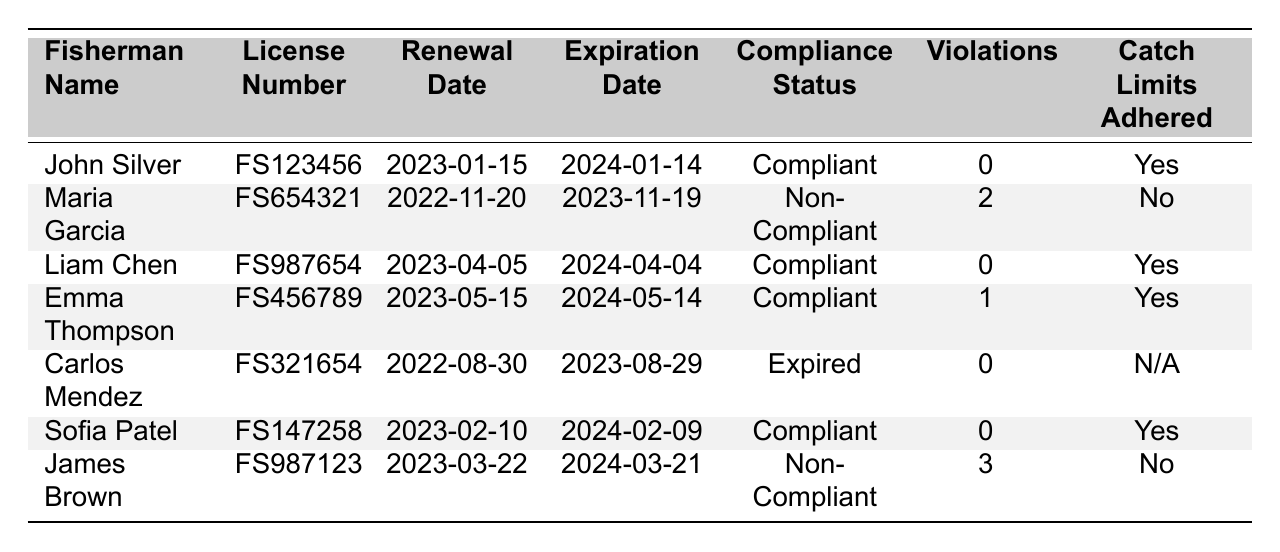What is the compliance status of Liam Chen? Liam Chen's compliance status is found in the "Compliance Status" column, directly corresponding to his name. He is marked as "Compliant".
Answer: Compliant How many violations does Maria Garcia have? Maria Garcia's number of violations is listed in the "Violations" column next to her name. She has 2 violations.
Answer: 2 What is the expiration date of John Silver's fishing license? The expiration date for John Silver can be found in the "Expiration Date" column associated with his name. His license expires on 2024-01-14.
Answer: 2024-01-14 Which fishermen have adhered to catch limits? Fishermen who adhered to catch limits are shown with "Yes" in the "Catch Limits Adhered" column. John Silver, Liam Chen, Emma Thompson, and Sofia Patel are compliant.
Answer: John Silver, Liam Chen, Emma Thompson, Sofia Patel How many fishermen are non-compliant? To find the number of non-compliant fishermen, count the number of times "Non-Compliant" appears in the "Compliance Status" column. There are 2 non-compliant fishermen: Maria Garcia and James Brown.
Answer: 2 What is the average number of violations among all fishermen? To calculate the average number of violations, sum all violations (0 + 2 + 0 + 1 + 0 + 0 + 3 = 6) and divide by the number of fishermen (7), resulting in an average of 6/7, which is approximately 0.86.
Answer: 0.86 Is Carlos Mendez compliant? Carlos Mendez's compliance status can be found in the "Compliance Status" column, and it shows that he has "Expired" status, which means he is not compliant.
Answer: No Which fisherman has the highest number of violations? Identifying the highest number of violations involves comparing all values in the "Violations" column. James Brown has the most with 3 violations.
Answer: James Brown When does Sofia Patel's license expire? Sofia Patel's license expiration date is listed in the "Expiration Date" column. Her license expires on 2024-02-09.
Answer: 2024-02-09 What percentage of fishermen are compliant? To find the percentage of compliant fishermen, divide the number of compliant fishermen (5) by the total number of fishermen (7), and multiply by 100: (5/7) * 100 ≈ 71.43%.
Answer: 71.43% 